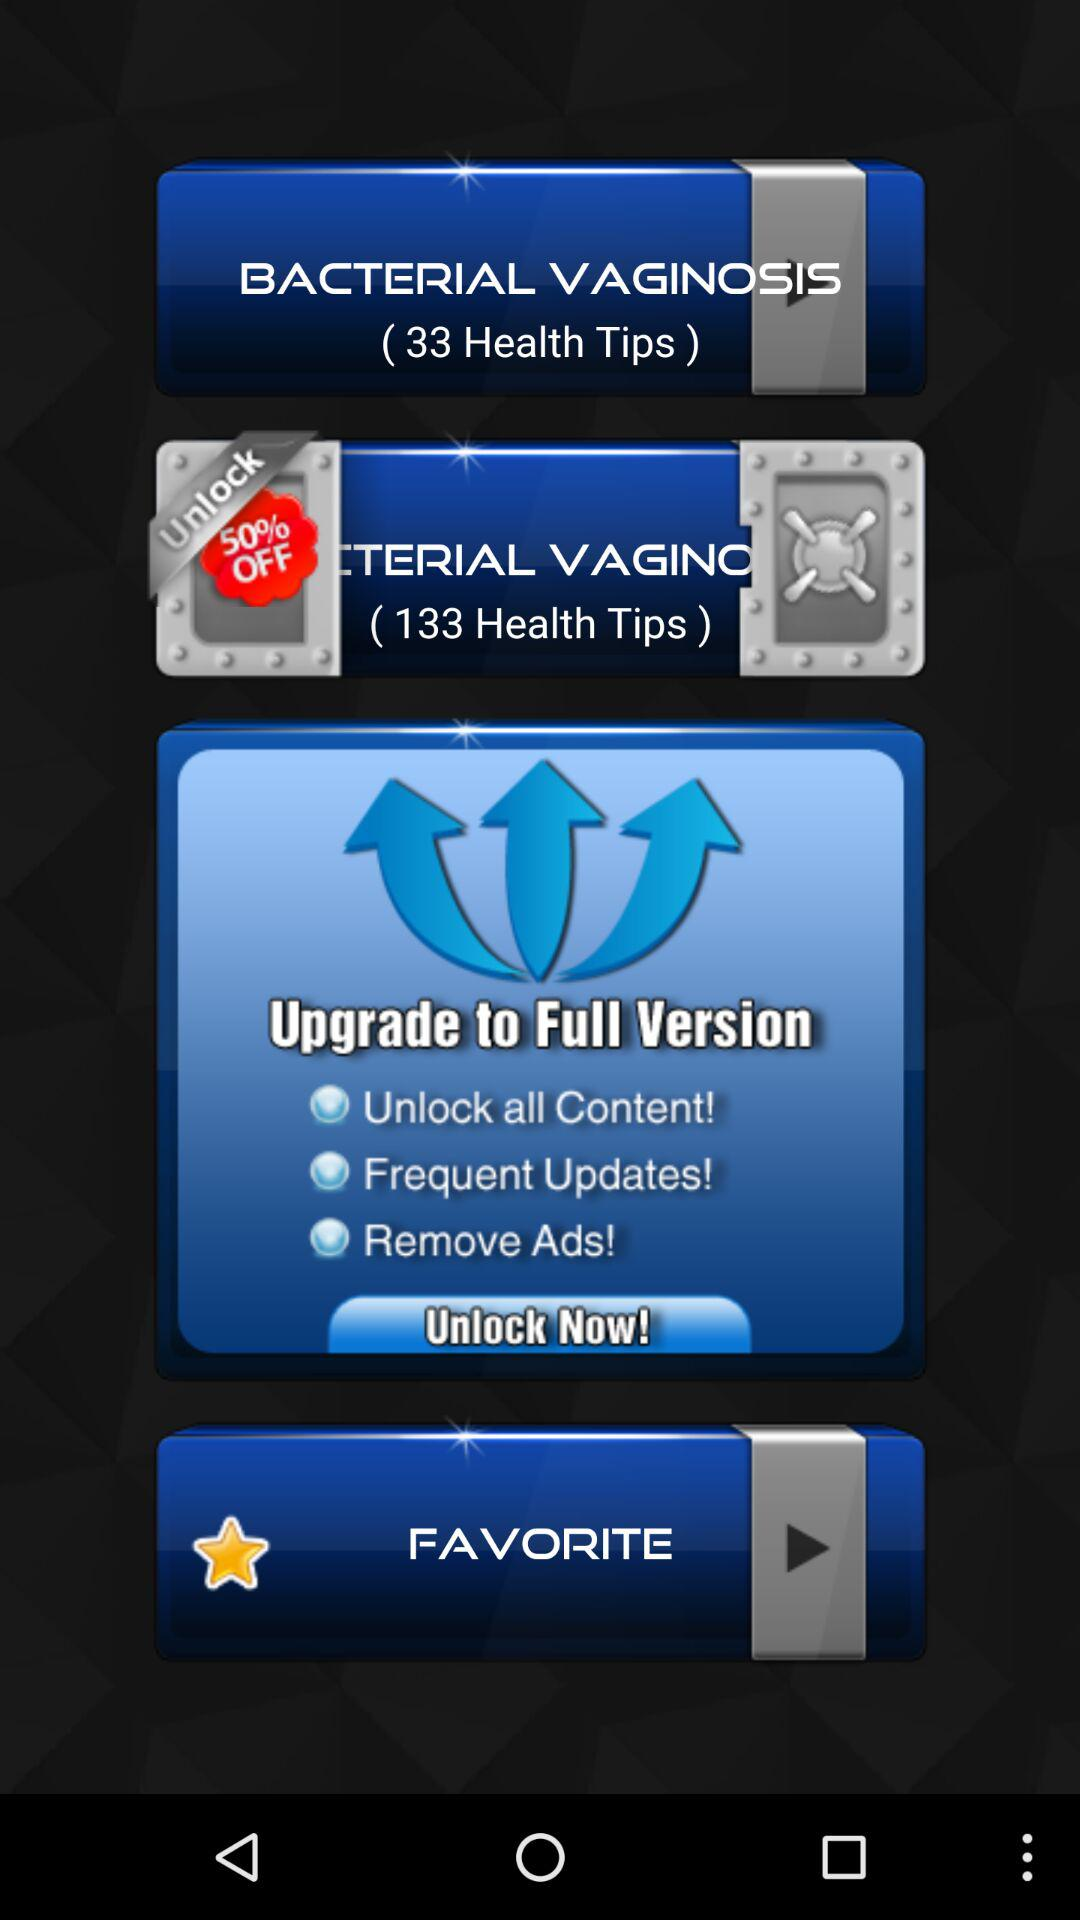How many more health tips are available in the full version than the free version?
Answer the question using a single word or phrase. 100 